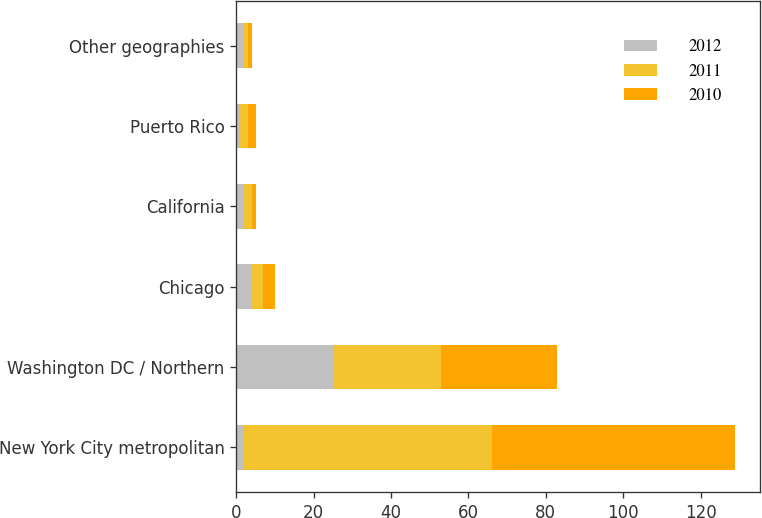Convert chart to OTSL. <chart><loc_0><loc_0><loc_500><loc_500><stacked_bar_chart><ecel><fcel>New York City metropolitan<fcel>Washington DC / Northern<fcel>Chicago<fcel>California<fcel>Puerto Rico<fcel>Other geographies<nl><fcel>2012<fcel>2<fcel>25<fcel>4<fcel>2<fcel>1<fcel>2<nl><fcel>2011<fcel>64<fcel>28<fcel>3<fcel>2<fcel>2<fcel>1<nl><fcel>2010<fcel>63<fcel>30<fcel>3<fcel>1<fcel>2<fcel>1<nl></chart> 